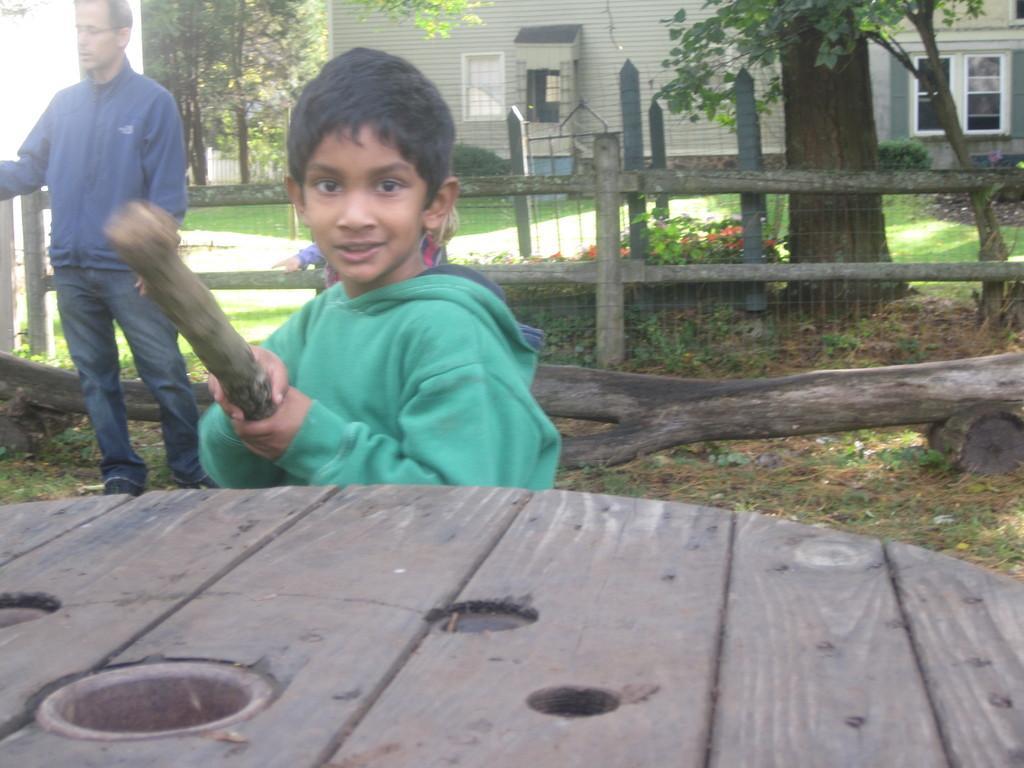Describe this image in one or two sentences. This is a picture taken in the outdoor. This is a boy who is in green hoodie holding a stick. On the right of the boy there is a table and left side of the boy there is a man who is in blue shirt. Background of this people there is a house, trees. 